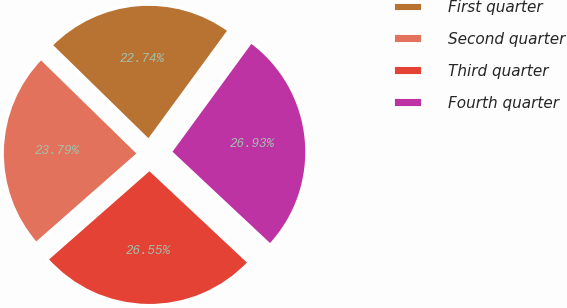Convert chart. <chart><loc_0><loc_0><loc_500><loc_500><pie_chart><fcel>First quarter<fcel>Second quarter<fcel>Third quarter<fcel>Fourth quarter<nl><fcel>22.74%<fcel>23.79%<fcel>26.55%<fcel>26.93%<nl></chart> 